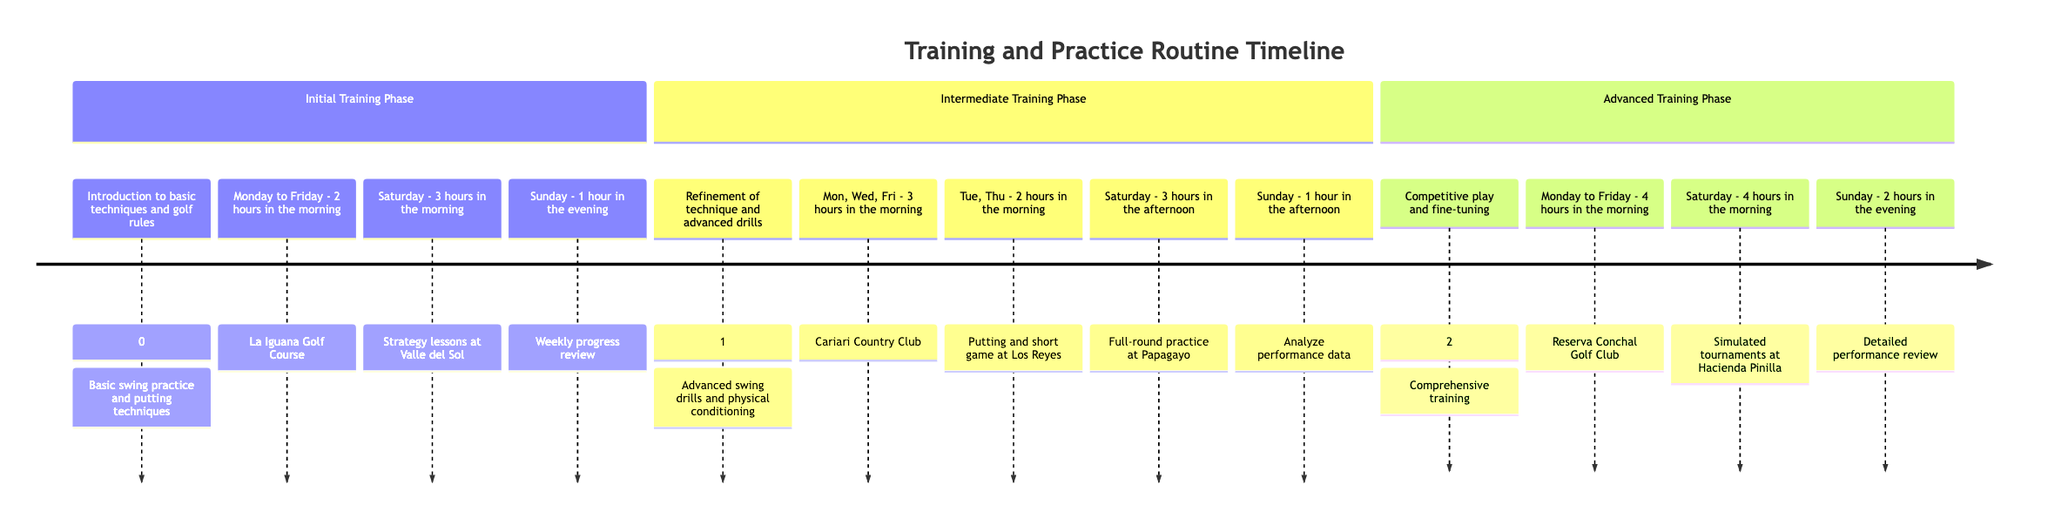What is the first stage in the timeline? The timeline starts with the "Initial Training Phase" stage, which is clearly labeled at the top of the first section of the diagram.
Answer: Initial Training Phase How many hours are dedicated to training on Saturday during the Intermediate Training Phase? During the Intermediate Training Phase, the Saturday training schedule allocates "3 hours in the afternoon" for full-round practice.
Answer: 3 hours What type of drills are introduced in the Intermediate Training Phase? In the Intermediate Training Phase, the focus is on the "Refinement of technique and introduction to advanced drills," as indicated in the description of that section.
Answer: Advanced drills What is the duration of the weekly progress review in the Advanced Training Phase? In the Advanced Training Phase, the weekly progress review is allocated "2 hours in the evening" on Sunday, which is specified in the activity details.
Answer: 2 hours Which golf course is mentioned for putting practice during the Initial Training Phase? The diagram specifically mentions "La Iguana Golf Course" as the location for basic swing practice and putting techniques during the Initial Training Phase.
Answer: La Iguana Golf Course How many total phases are depicted in the timeline? The timeline consists of three clearly defined phases: Initial, Intermediate, and Advanced, visible in the section headers.
Answer: 3 What activities are scheduled for Monday and Tuesday during the Intermediate Training Phase? The Monday schedule includes "3 hours in the morning" for advanced swing drills, while Tuesday includes "2 hours in the morning" for putting and short game practice, as outlined in the respective sections.
Answer: Advanced swing drills and putting practice What is the key focus during the Advanced Training Phase? The key focus during the Advanced Training Phase is "competitive play and fine-tuning," which is stated in the phase description at the beginning of that section.
Answer: Competitive play What time do training activities typically start during the Advanced Training Phase? All training activities during the Advanced Training Phase generally start "in the morning," as stated for both weekdays and Saturday in that section.
Answer: Morning 